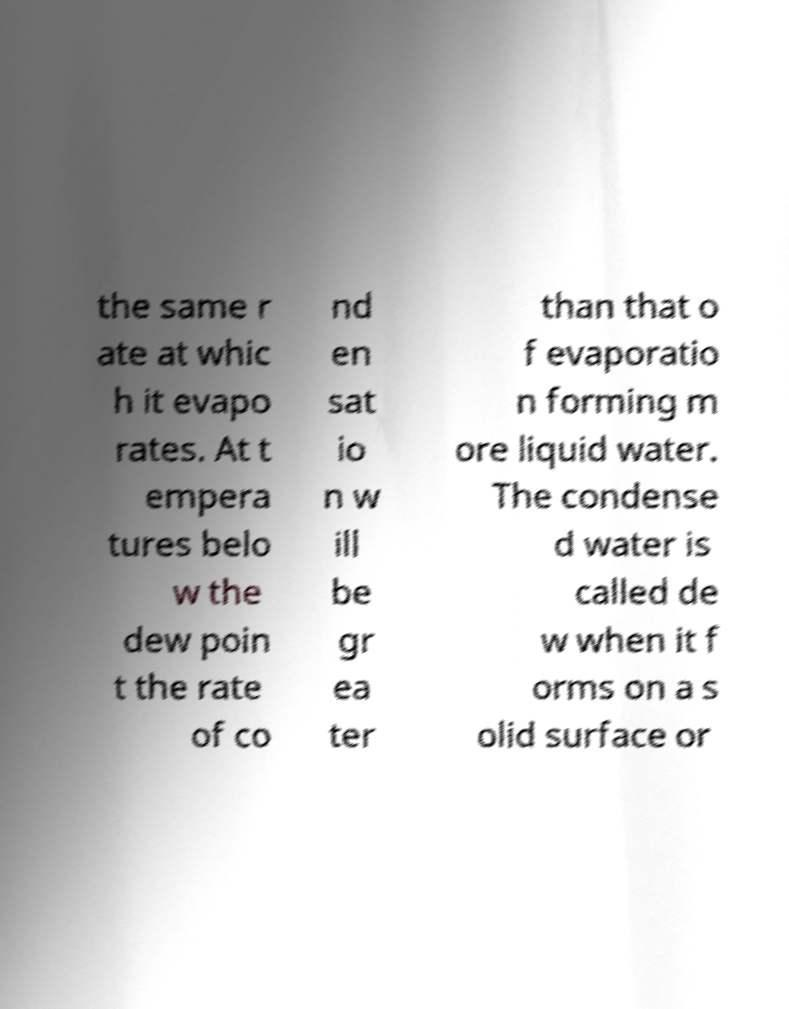Can you accurately transcribe the text from the provided image for me? the same r ate at whic h it evapo rates. At t empera tures belo w the dew poin t the rate of co nd en sat io n w ill be gr ea ter than that o f evaporatio n forming m ore liquid water. The condense d water is called de w when it f orms on a s olid surface or 